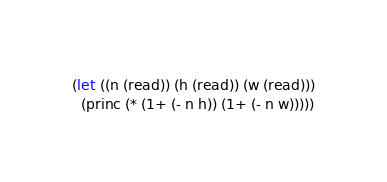<code> <loc_0><loc_0><loc_500><loc_500><_Lisp_>(let ((n (read)) (h (read)) (w (read)))
  (princ (* (1+ (- n h)) (1+ (- n w)))))
</code> 